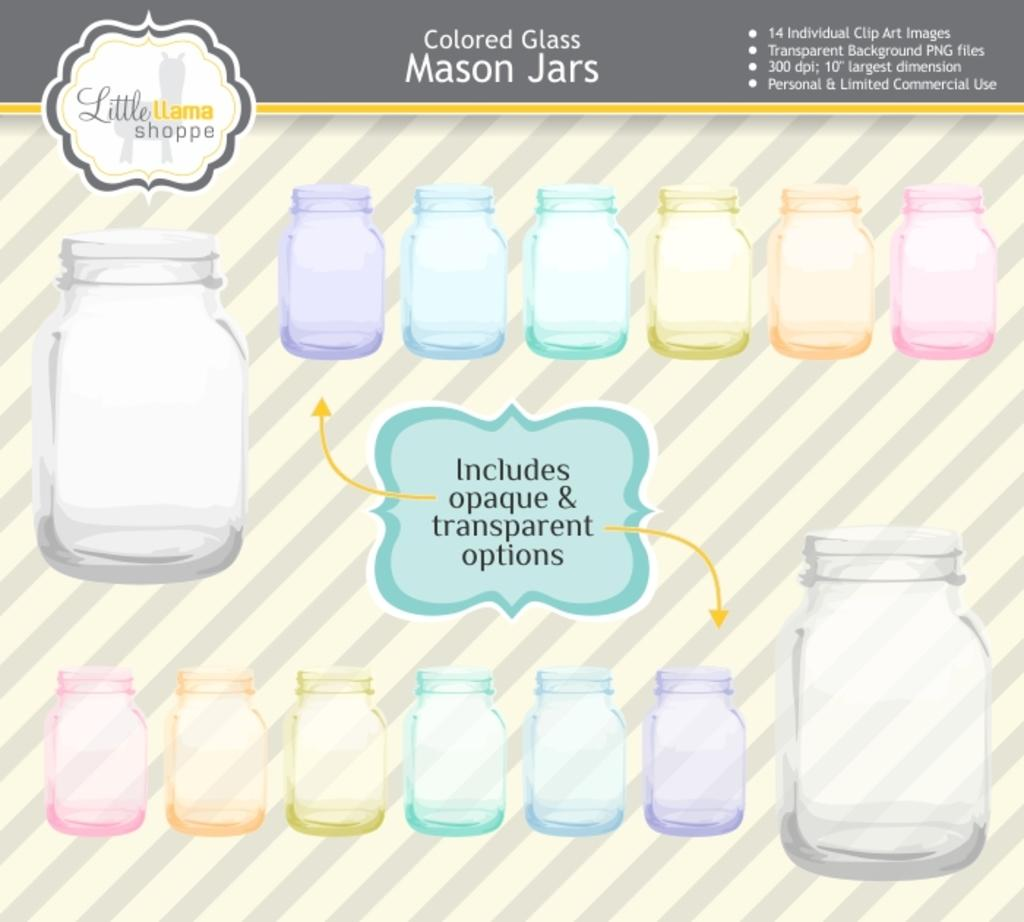<image>
Create a compact narrative representing the image presented. An advertisment for different colored Mason Jars with a notice saying that they include both opaque and transparent options. 